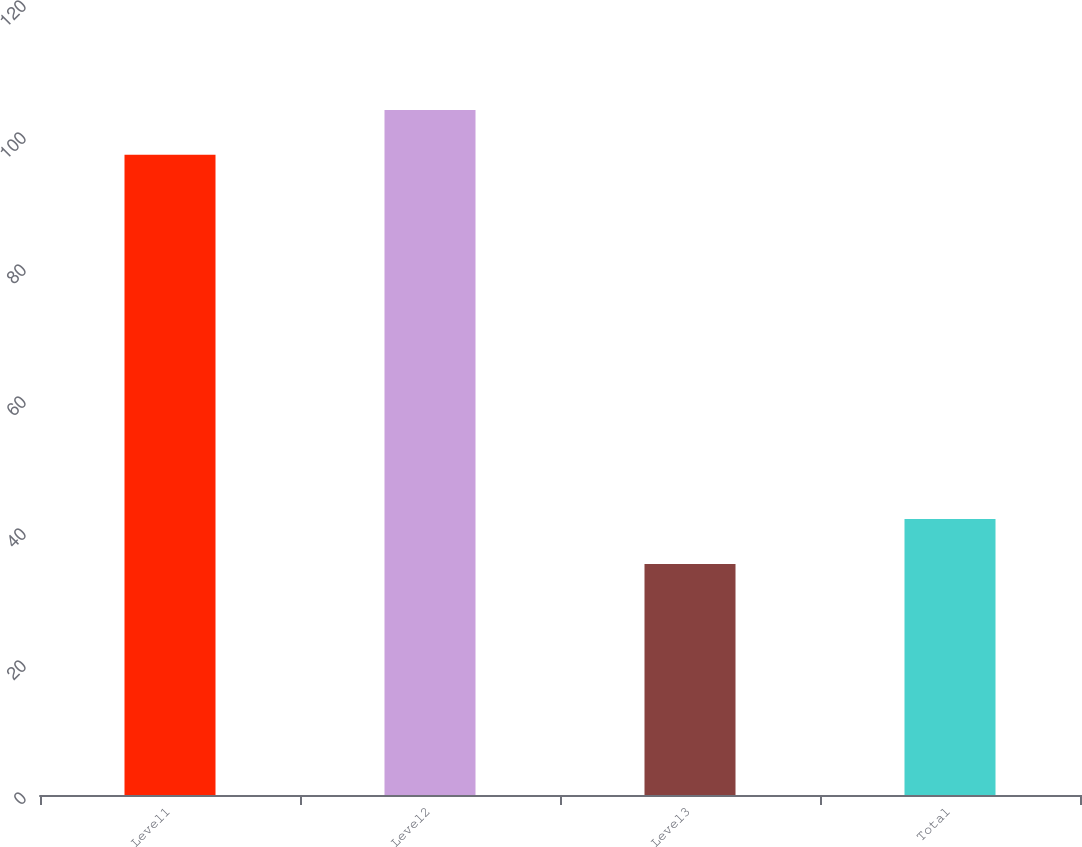Convert chart. <chart><loc_0><loc_0><loc_500><loc_500><bar_chart><fcel>Level1<fcel>Level2<fcel>Level3<fcel>Total<nl><fcel>97<fcel>103.8<fcel>35<fcel>41.8<nl></chart> 